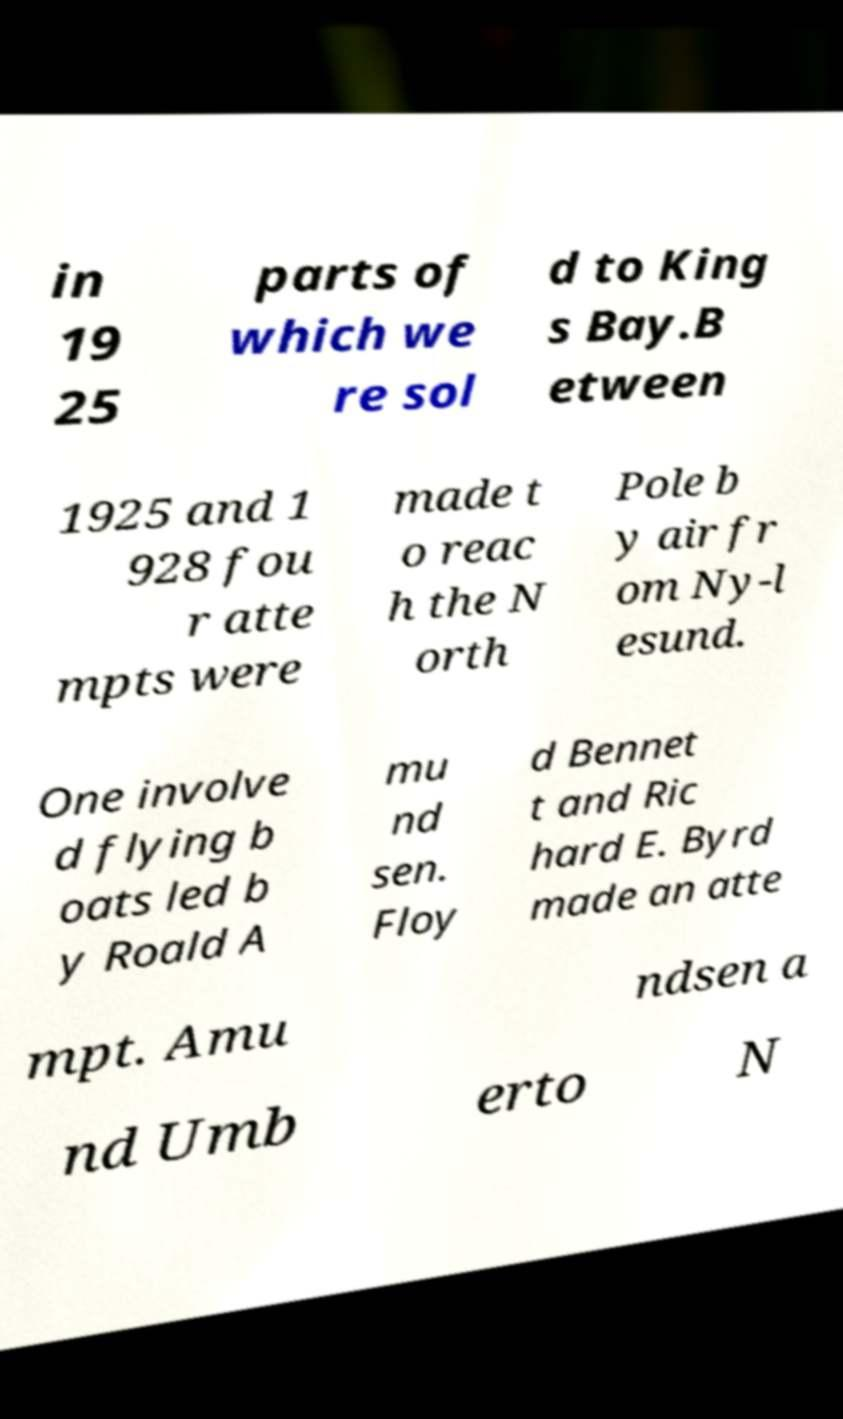Could you extract and type out the text from this image? in 19 25 parts of which we re sol d to King s Bay.B etween 1925 and 1 928 fou r atte mpts were made t o reac h the N orth Pole b y air fr om Ny-l esund. One involve d flying b oats led b y Roald A mu nd sen. Floy d Bennet t and Ric hard E. Byrd made an atte mpt. Amu ndsen a nd Umb erto N 